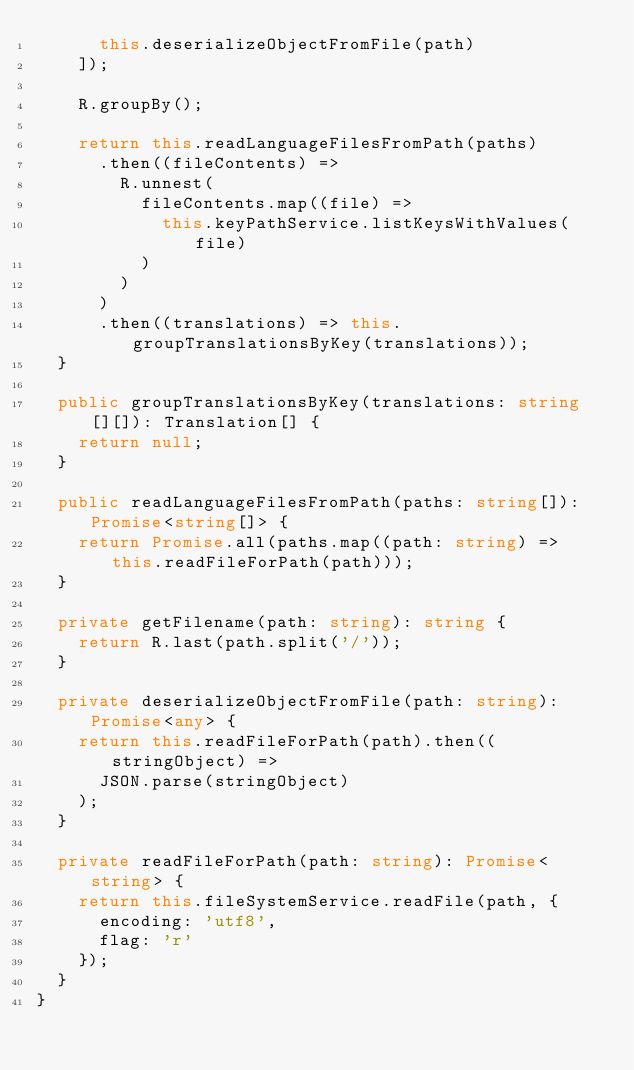<code> <loc_0><loc_0><loc_500><loc_500><_TypeScript_>      this.deserializeObjectFromFile(path)
    ]);

    R.groupBy();

    return this.readLanguageFilesFromPath(paths)
      .then((fileContents) =>
        R.unnest(
          fileContents.map((file) =>
            this.keyPathService.listKeysWithValues(file)
          )
        )
      )
      .then((translations) => this.groupTranslationsByKey(translations));
  }

  public groupTranslationsByKey(translations: string[][]): Translation[] {
    return null;
  }

  public readLanguageFilesFromPath(paths: string[]): Promise<string[]> {
    return Promise.all(paths.map((path: string) => this.readFileForPath(path)));
  }

  private getFilename(path: string): string {
    return R.last(path.split('/'));
  }

  private deserializeObjectFromFile(path: string): Promise<any> {
    return this.readFileForPath(path).then((stringObject) =>
      JSON.parse(stringObject)
    );
  }

  private readFileForPath(path: string): Promise<string> {
    return this.fileSystemService.readFile(path, {
      encoding: 'utf8',
      flag: 'r'
    });
  }
}
</code> 